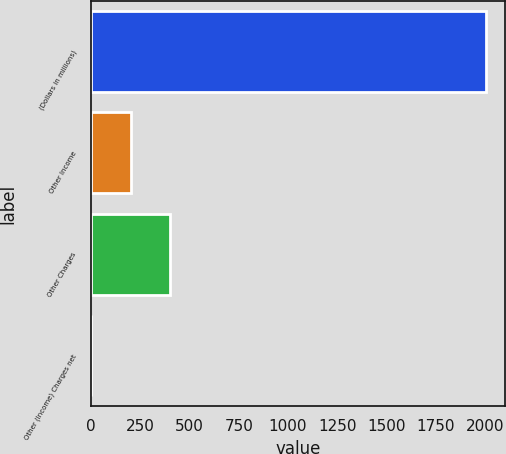<chart> <loc_0><loc_0><loc_500><loc_500><bar_chart><fcel>(Dollars in millions)<fcel>Other Income<fcel>Other Charges<fcel>Other (Income) Charges net<nl><fcel>2002<fcel>202<fcel>402<fcel>2<nl></chart> 